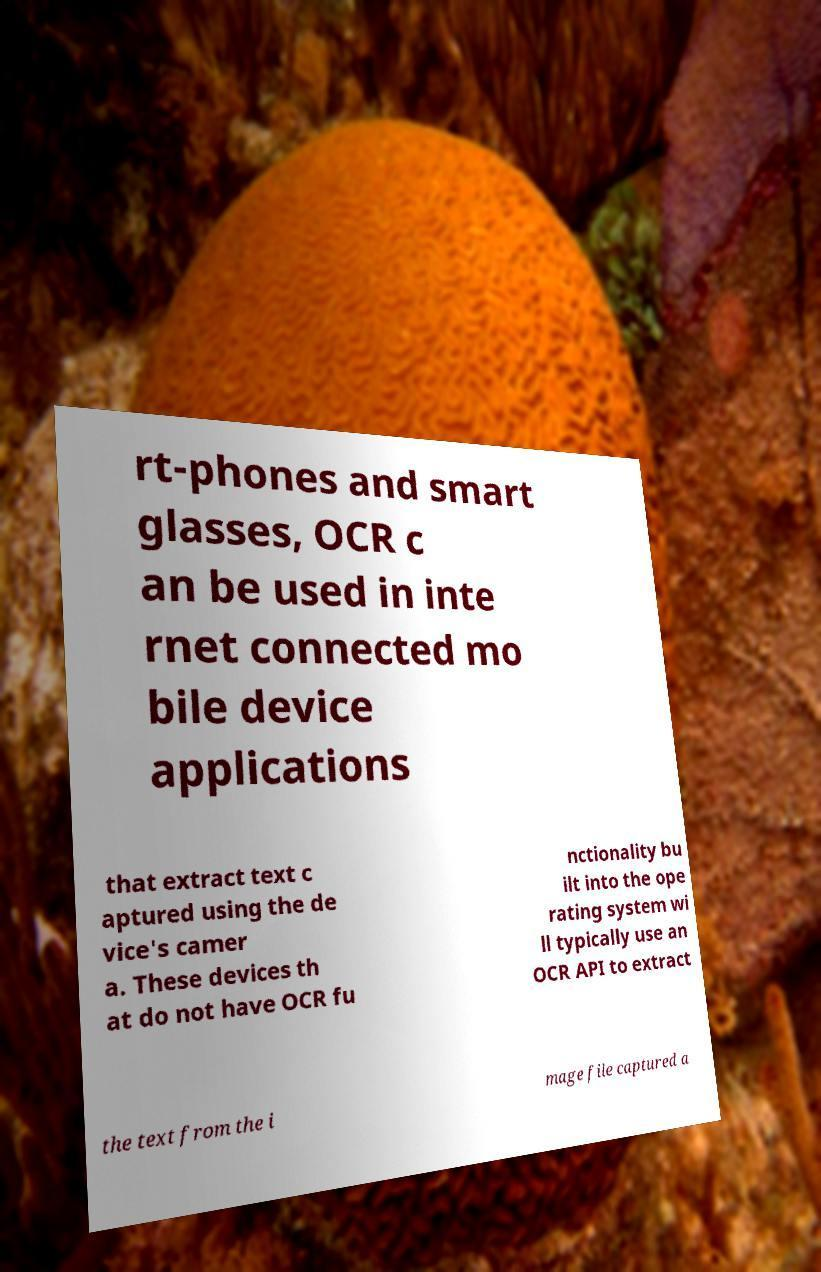What messages or text are displayed in this image? I need them in a readable, typed format. rt-phones and smart glasses, OCR c an be used in inte rnet connected mo bile device applications that extract text c aptured using the de vice's camer a. These devices th at do not have OCR fu nctionality bu ilt into the ope rating system wi ll typically use an OCR API to extract the text from the i mage file captured a 